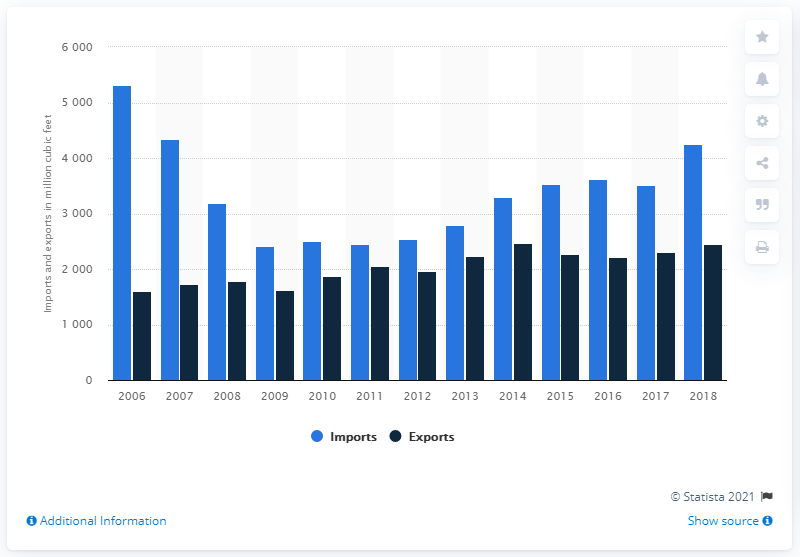Give some essential details in this illustration. In 2018, the amount of industrial roundwood imports in the United States was 4,258 thousand cubic meters. In 2018, a total of 2457 cubic feet of industrial roundwood were exported in the United States. 